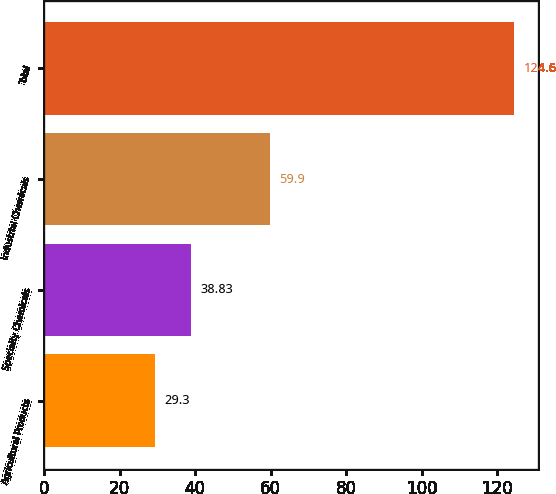Convert chart to OTSL. <chart><loc_0><loc_0><loc_500><loc_500><bar_chart><fcel>Agricultural Products<fcel>Specialty Chemicals<fcel>Industrial Chemicals<fcel>Total<nl><fcel>29.3<fcel>38.83<fcel>59.9<fcel>124.6<nl></chart> 